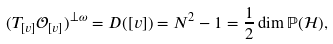<formula> <loc_0><loc_0><loc_500><loc_500>( T _ { [ v ] } \mathcal { O } _ { [ v ] } ) ^ { \perp \omega } = D ( [ v ] ) = N ^ { 2 } - 1 = \frac { 1 } { 2 } \dim \mathbb { P } ( \mathcal { H } ) ,</formula> 